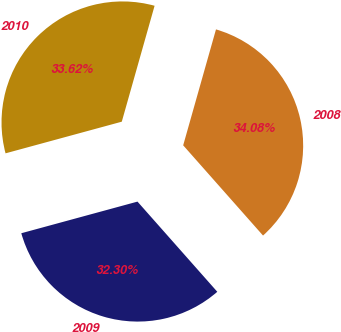Convert chart to OTSL. <chart><loc_0><loc_0><loc_500><loc_500><pie_chart><fcel>2010<fcel>2009<fcel>2008<nl><fcel>33.62%<fcel>32.3%<fcel>34.08%<nl></chart> 